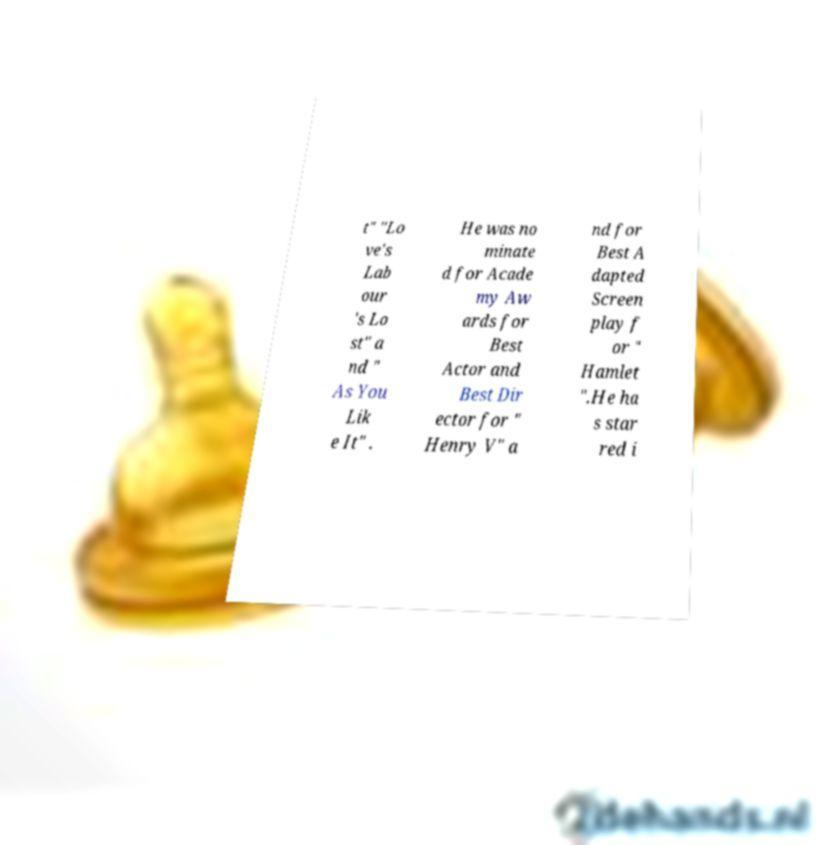There's text embedded in this image that I need extracted. Can you transcribe it verbatim? t" "Lo ve's Lab our 's Lo st" a nd " As You Lik e It" . He was no minate d for Acade my Aw ards for Best Actor and Best Dir ector for " Henry V" a nd for Best A dapted Screen play f or " Hamlet ".He ha s star red i 